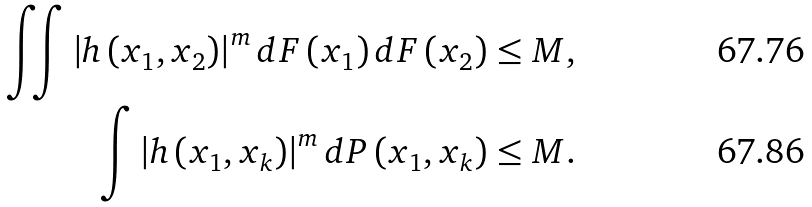Convert formula to latex. <formula><loc_0><loc_0><loc_500><loc_500>\iint \left | h \left ( x _ { 1 } , x _ { 2 } \right ) \right | ^ { m } d F \left ( x _ { 1 } \right ) d F \left ( x _ { 2 } \right ) & \leq M , \\ \int \left | h \left ( x _ { 1 } , x _ { k } \right ) \right | ^ { m } d P \left ( x _ { 1 } , x _ { k } \right ) & \leq M .</formula> 